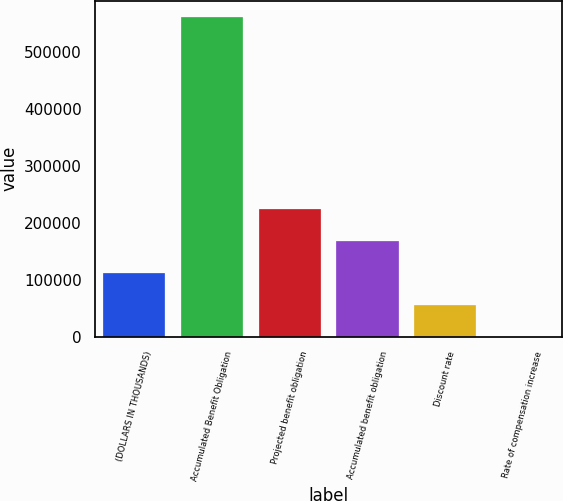Convert chart. <chart><loc_0><loc_0><loc_500><loc_500><bar_chart><fcel>(DOLLARS IN THOUSANDS)<fcel>Accumulated Benefit Obligation<fcel>Projected benefit obligation<fcel>Accumulated benefit obligation<fcel>Discount rate<fcel>Rate of compensation increase<nl><fcel>112411<fcel>562043<fcel>224819<fcel>168615<fcel>56207.2<fcel>3.25<nl></chart> 